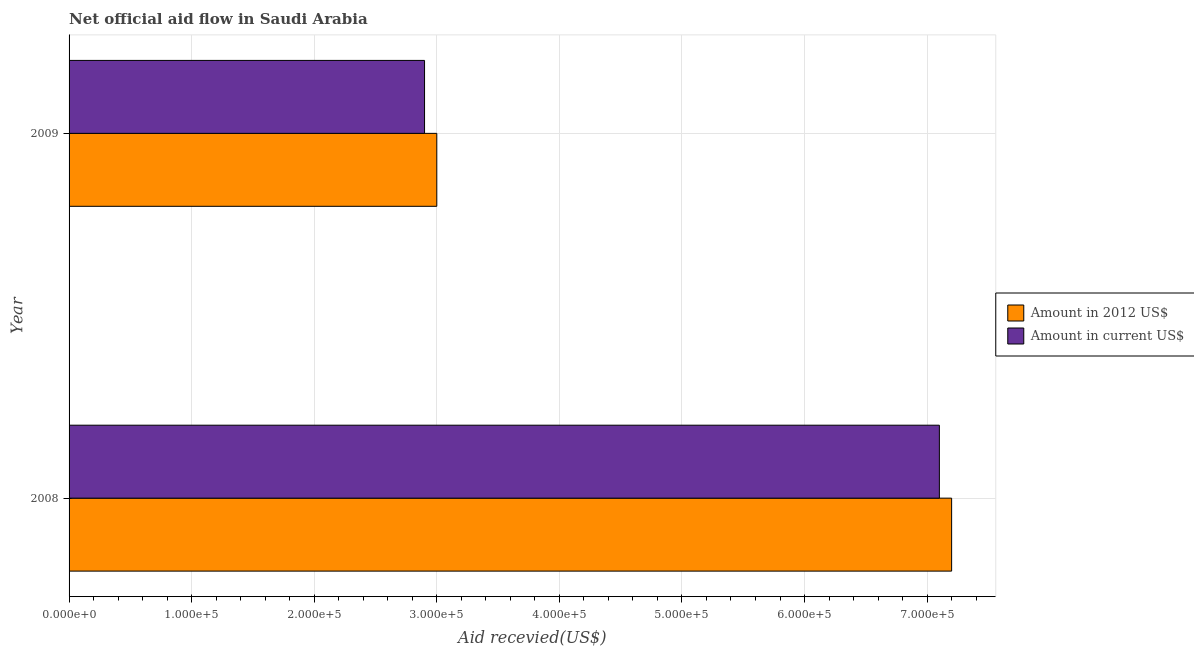How many different coloured bars are there?
Offer a terse response. 2. What is the label of the 1st group of bars from the top?
Offer a very short reply. 2009. What is the amount of aid received(expressed in us$) in 2009?
Offer a terse response. 2.90e+05. Across all years, what is the maximum amount of aid received(expressed in 2012 us$)?
Your response must be concise. 7.20e+05. Across all years, what is the minimum amount of aid received(expressed in us$)?
Make the answer very short. 2.90e+05. In which year was the amount of aid received(expressed in us$) maximum?
Provide a short and direct response. 2008. What is the total amount of aid received(expressed in us$) in the graph?
Give a very brief answer. 1.00e+06. What is the difference between the amount of aid received(expressed in 2012 us$) in 2008 and that in 2009?
Ensure brevity in your answer.  4.20e+05. What is the difference between the amount of aid received(expressed in us$) in 2009 and the amount of aid received(expressed in 2012 us$) in 2008?
Your answer should be compact. -4.30e+05. In the year 2008, what is the difference between the amount of aid received(expressed in 2012 us$) and amount of aid received(expressed in us$)?
Your response must be concise. 10000. In how many years, is the amount of aid received(expressed in us$) greater than 260000 US$?
Your response must be concise. 2. Is the amount of aid received(expressed in us$) in 2008 less than that in 2009?
Give a very brief answer. No. What does the 1st bar from the top in 2009 represents?
Ensure brevity in your answer.  Amount in current US$. What does the 2nd bar from the bottom in 2009 represents?
Provide a succinct answer. Amount in current US$. How many bars are there?
Provide a short and direct response. 4. How many years are there in the graph?
Give a very brief answer. 2. What is the difference between two consecutive major ticks on the X-axis?
Give a very brief answer. 1.00e+05. Does the graph contain any zero values?
Your answer should be compact. No. Where does the legend appear in the graph?
Your response must be concise. Center right. How are the legend labels stacked?
Your answer should be compact. Vertical. What is the title of the graph?
Ensure brevity in your answer.  Net official aid flow in Saudi Arabia. Does "Travel Items" appear as one of the legend labels in the graph?
Make the answer very short. No. What is the label or title of the X-axis?
Ensure brevity in your answer.  Aid recevied(US$). What is the label or title of the Y-axis?
Offer a terse response. Year. What is the Aid recevied(US$) in Amount in 2012 US$ in 2008?
Offer a terse response. 7.20e+05. What is the Aid recevied(US$) of Amount in current US$ in 2008?
Offer a terse response. 7.10e+05. What is the Aid recevied(US$) in Amount in 2012 US$ in 2009?
Ensure brevity in your answer.  3.00e+05. What is the Aid recevied(US$) of Amount in current US$ in 2009?
Provide a succinct answer. 2.90e+05. Across all years, what is the maximum Aid recevied(US$) in Amount in 2012 US$?
Offer a very short reply. 7.20e+05. Across all years, what is the maximum Aid recevied(US$) in Amount in current US$?
Your answer should be compact. 7.10e+05. Across all years, what is the minimum Aid recevied(US$) in Amount in current US$?
Keep it short and to the point. 2.90e+05. What is the total Aid recevied(US$) of Amount in 2012 US$ in the graph?
Offer a very short reply. 1.02e+06. What is the total Aid recevied(US$) of Amount in current US$ in the graph?
Provide a short and direct response. 1.00e+06. What is the average Aid recevied(US$) in Amount in 2012 US$ per year?
Offer a very short reply. 5.10e+05. What is the average Aid recevied(US$) of Amount in current US$ per year?
Your answer should be very brief. 5.00e+05. In the year 2008, what is the difference between the Aid recevied(US$) in Amount in 2012 US$ and Aid recevied(US$) in Amount in current US$?
Your answer should be very brief. 10000. What is the ratio of the Aid recevied(US$) of Amount in current US$ in 2008 to that in 2009?
Your answer should be compact. 2.45. What is the difference between the highest and the second highest Aid recevied(US$) of Amount in 2012 US$?
Give a very brief answer. 4.20e+05. What is the difference between the highest and the second highest Aid recevied(US$) of Amount in current US$?
Your response must be concise. 4.20e+05. What is the difference between the highest and the lowest Aid recevied(US$) of Amount in 2012 US$?
Ensure brevity in your answer.  4.20e+05. What is the difference between the highest and the lowest Aid recevied(US$) of Amount in current US$?
Ensure brevity in your answer.  4.20e+05. 